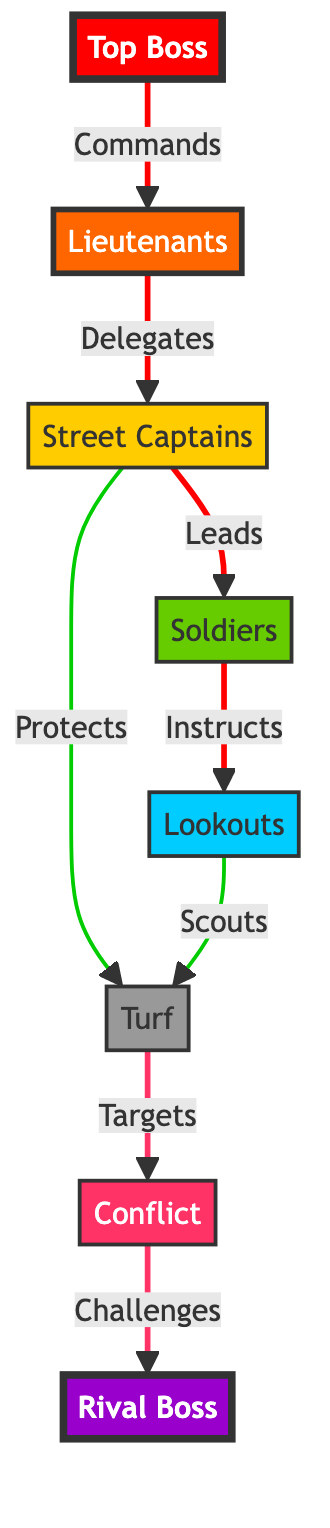What's the main authority in the diagram? The diagram shows "Top Boss" at the apex, indicating that this figure commands the entire operation and hierarchy.
Answer: Top Boss How many tiers of hierarchy are present in the diagram? The diagram outlines a structure consisting of four tiers: Top Boss, Lieutenants, Street Captains, and Soldiers, along with Lookouts.
Answer: Four Who protects the turf? The "Street Captains" are specifically indicated as the group that "Protects" the turf as shown in the flow from C to G.
Answer: Street Captains What role do lookouts play in the hierarchy? Lookouts are shown as part of the operational tier, where they "Scout" the turf, indicating their role in providing intelligence on the territory.
Answer: Scouts Which node represents the challenge to the territory? "Conflict" is directly indicated by the link as the entity that "Challenges" the Rival Boss, representing the potential for territorial disputes.
Answer: Conflict Which nodes are connected with a protective action? The link between "Street Captains" and "Turf" signifies the protective action, confirming that Street Captains are responsible for defense.
Answer: Street Captains and Turf What color represents the rival boss? In the diagram, the "Rival Boss" is represented with the color purple (#9900CC), indicating a strong and significant opposing force.
Answer: Purple What action is taken by the turf towards the rival? The turf "Targets" the rival, indicating an aggressive stance or intent towards the opposing gang led by the Rival Boss.
Answer: Targets How are soldiers positioned in relation to the street captains? Soldiers are indicated as directly below "Street Captains," demonstrating a clear hierarchical relationship where Captains lead Soldiers.
Answer: Below 